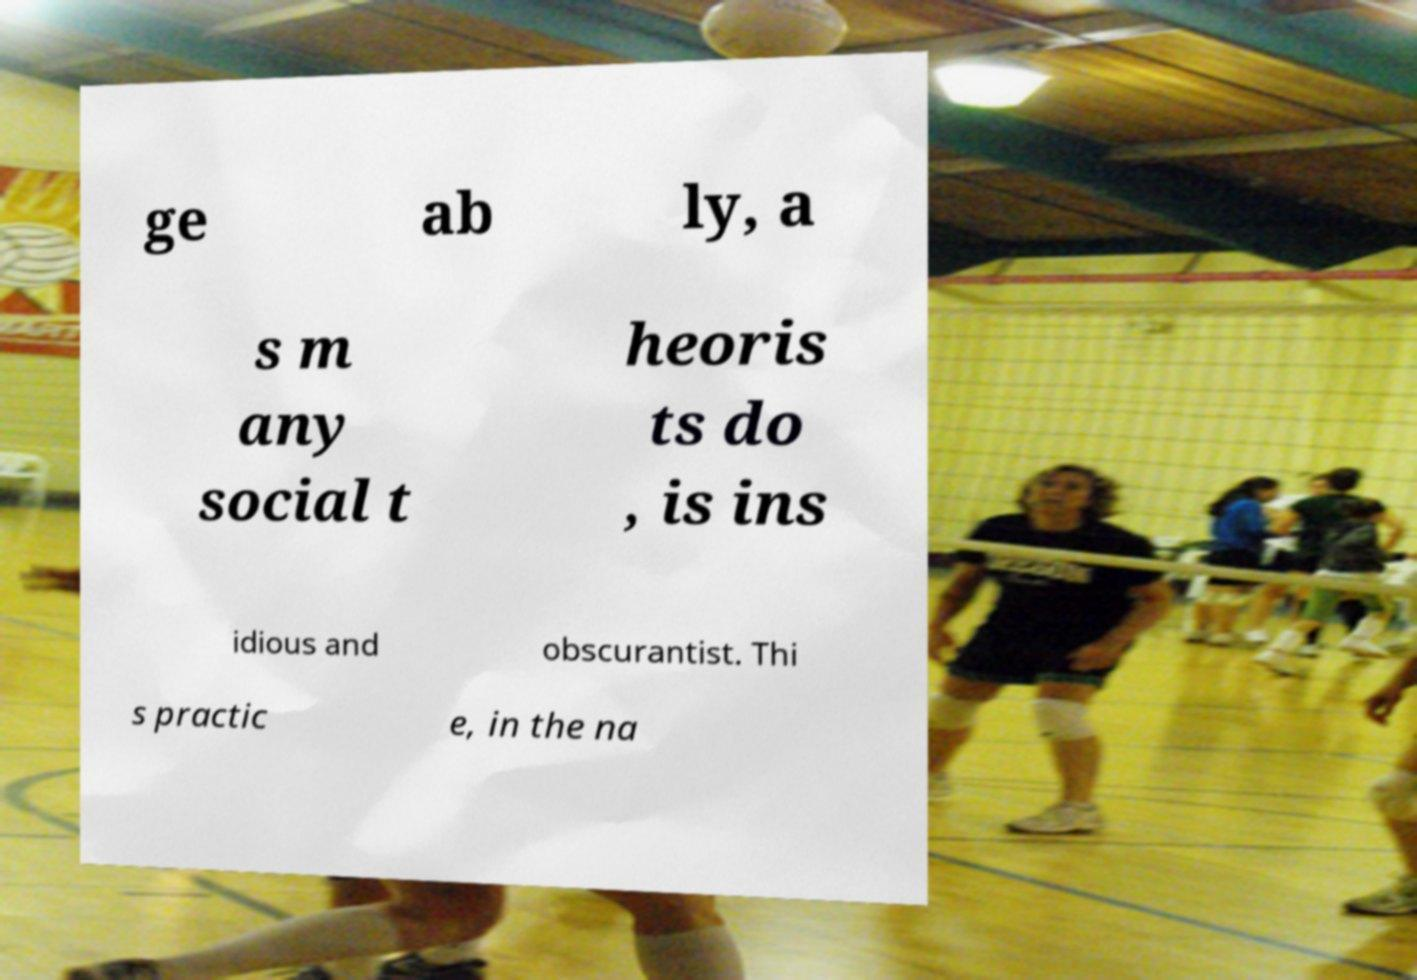Can you accurately transcribe the text from the provided image for me? ge ab ly, a s m any social t heoris ts do , is ins idious and obscurantist. Thi s practic e, in the na 